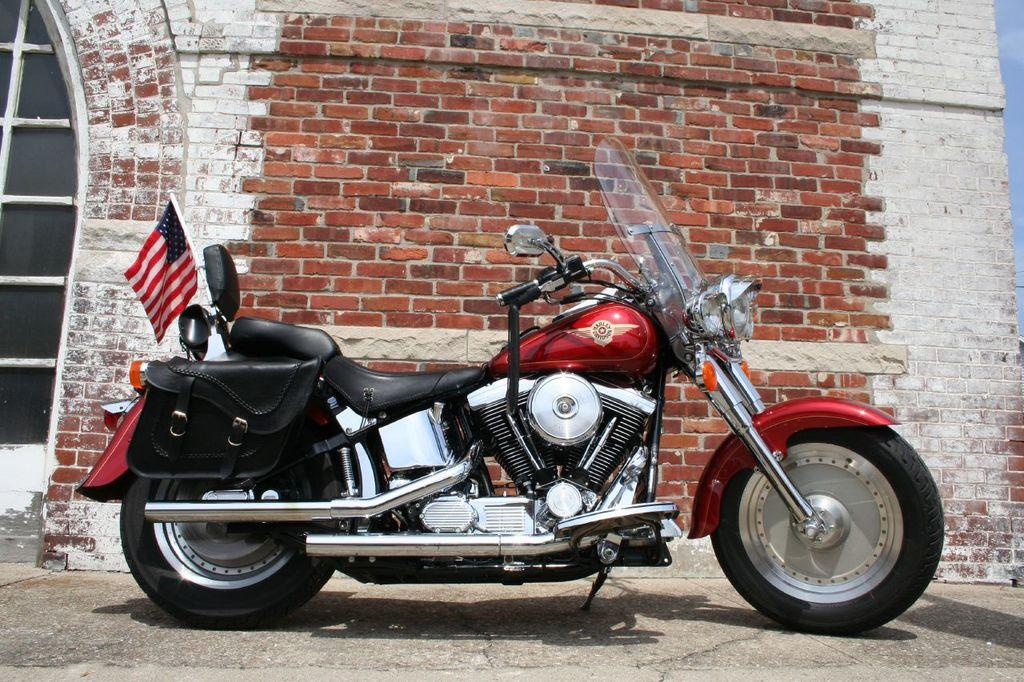What type of vehicle is on the ground in the image? There is a motorcycle on the ground in the image. What is the background of the image made of? There is a brick wall in the image. Is there any opening in the brick wall? Yes, there is a window in the image. What can be seen above the brick wall and window? The sky is visible in the image. What type of nut is used to hold the motorcycle together in the image? There is no mention of nuts or any mechanical components in the image; it simply shows a motorcycle on the ground. 